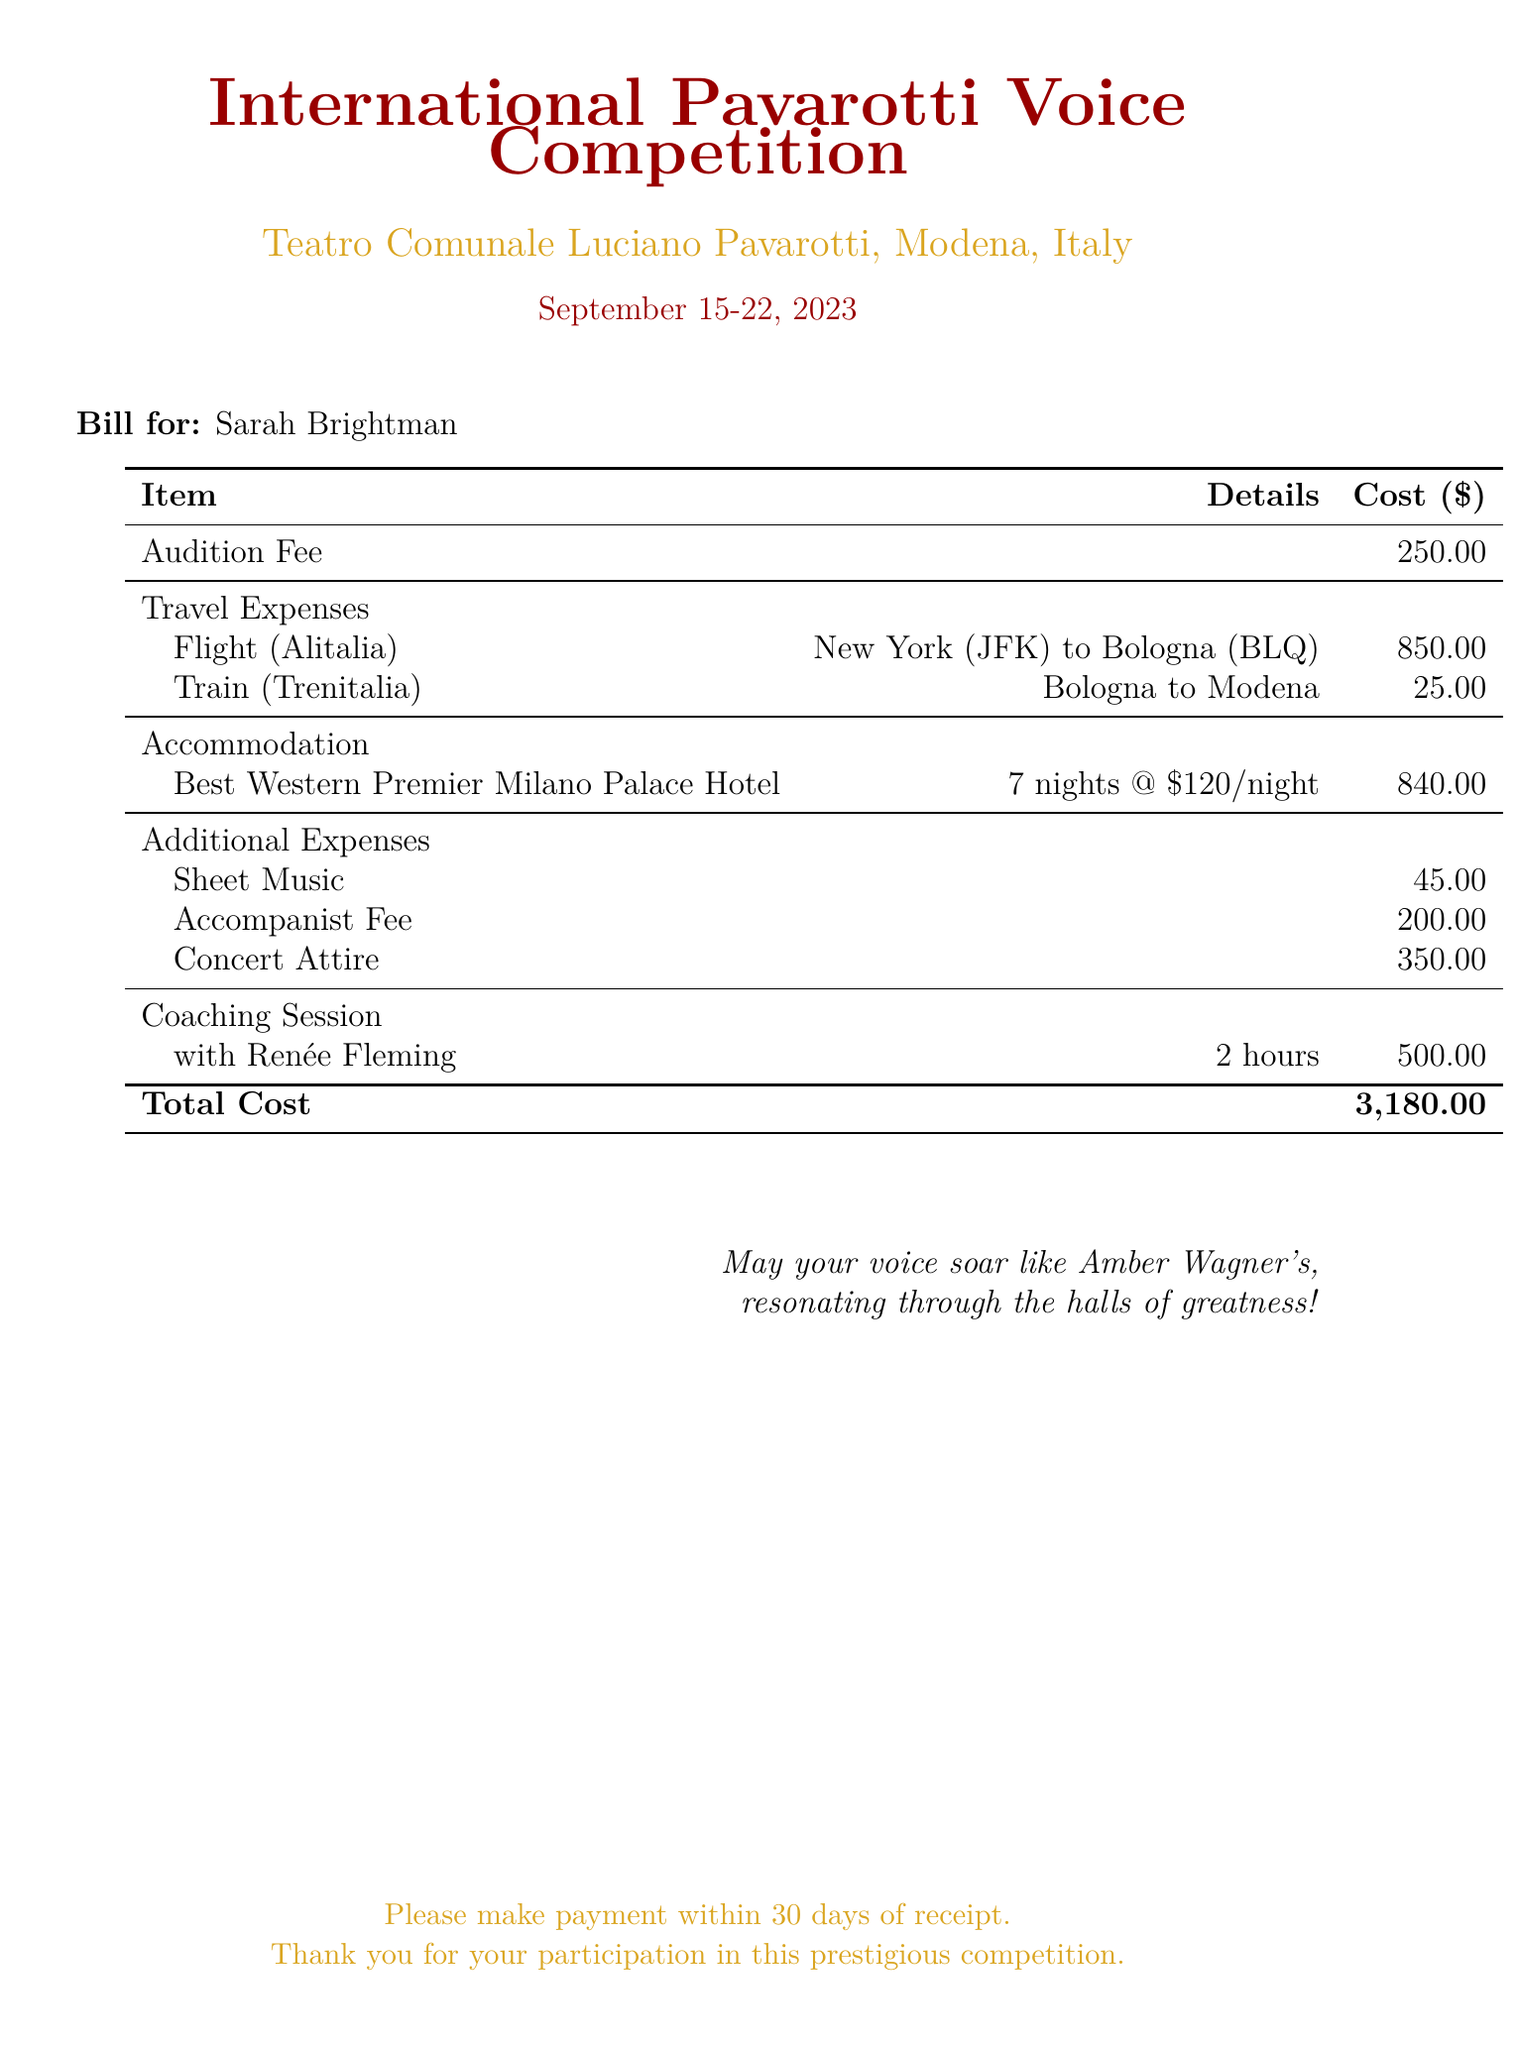What is the total cost of the bill? The total cost is clearly stated at the bottom of the bill.
Answer: 3,180.00 What is the audition fee? The audition fee is listed as a specific line item in the document.
Answer: 250.00 Who is the bill addressed to? The name at the top of the bill specifies the individual the bill is for.
Answer: Sarah Brightman How many nights is the accommodation for? The number of nights is mentioned in the accommodation details.
Answer: 7 nights What is the name of the hotel? The hotel name is provided in the accommodation section of the bill.
Answer: Best Western Premier Milano Palace Hotel What is the cost of the flight? The flight cost is detailed in the travel expenses section.
Answer: 850.00 How much is the coaching session with Renée Fleming? The bill specifies the cost for the coaching session in a separate section.
Answer: 500.00 What is the date range of the competition? The date range for the competition appears at the beginning of the document.
Answer: September 15-22, 2023 What is the due date for payment? Payment terms are mentioned at the end of the document.
Answer: Within 30 days of receipt 